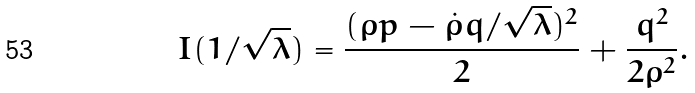Convert formula to latex. <formula><loc_0><loc_0><loc_500><loc_500>I ( 1 / \sqrt { \lambda } ) = \frac { ( \rho p - \dot { \rho } q / \sqrt { \lambda } ) ^ { 2 } } { 2 } + \frac { q ^ { 2 } } { 2 \rho ^ { 2 } } .</formula> 